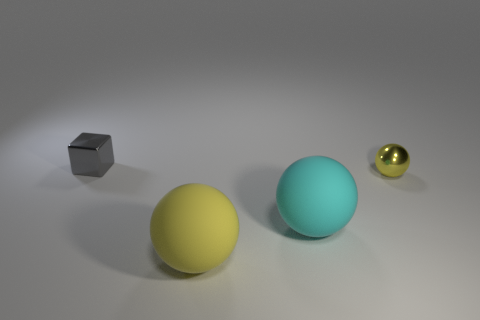How do the sizes of the different objects compare? The objects present in the image vary in size. The gray cube is the smallest, followed by the golden sphere, with the yellow and light blue spheres being larger and quite similar in size. 